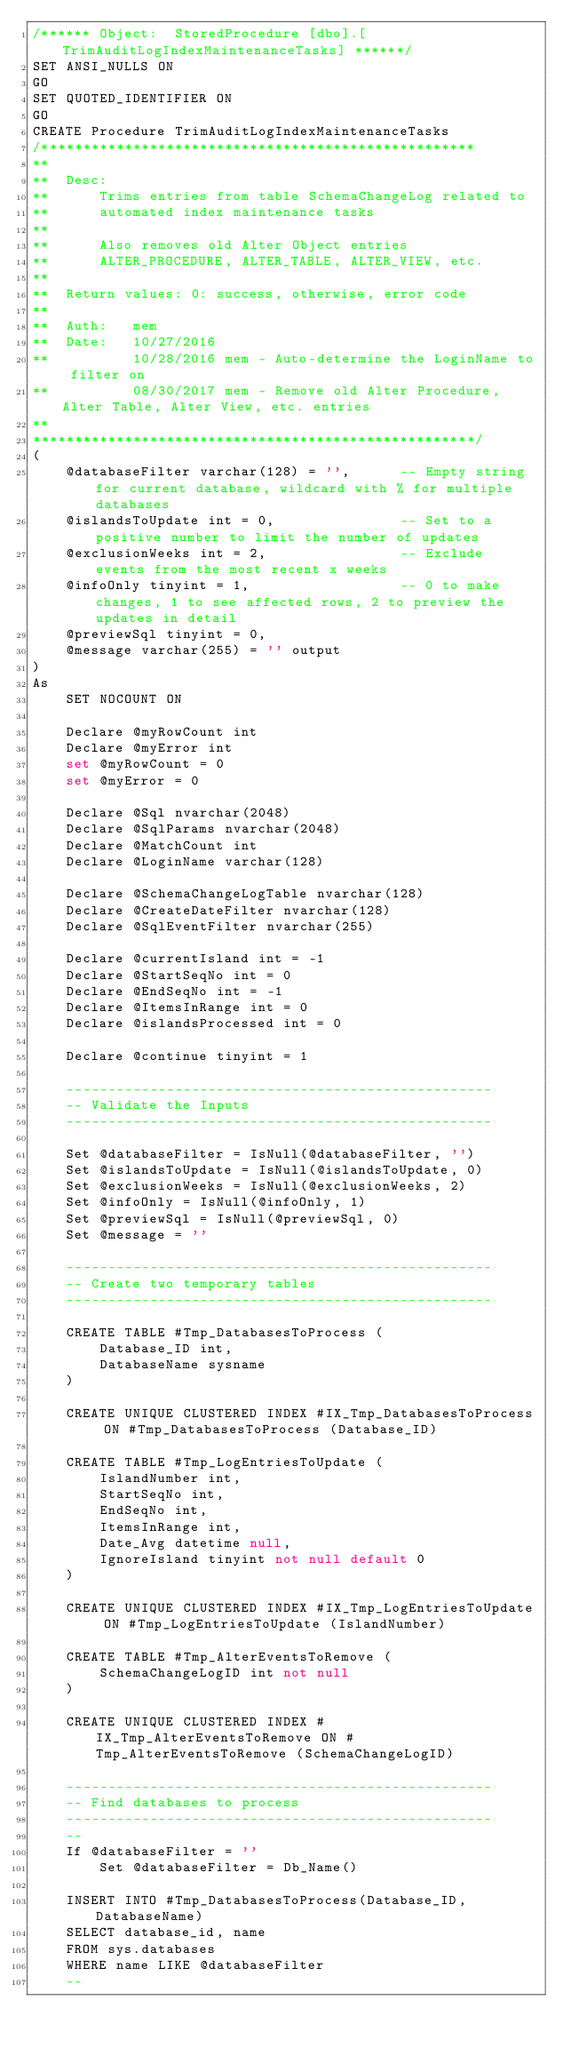<code> <loc_0><loc_0><loc_500><loc_500><_SQL_>/****** Object:  StoredProcedure [dbo].[TrimAuditLogIndexMaintenanceTasks] ******/
SET ANSI_NULLS ON
GO
SET QUOTED_IDENTIFIER ON
GO
CREATE Procedure TrimAuditLogIndexMaintenanceTasks
/****************************************************
**
**	Desc: 
**		Trims entries from table SchemaChangeLog related to
**		automated index maintenance tasks
**
**		Also removes old Alter Object entries
**		ALTER_PROCEDURE, ALTER_TABLE, ALTER_VIEW, etc.
**
**	Return values: 0: success, otherwise, error code
**
**	Auth:	mem
**	Date:	10/27/2016
**			10/28/2016 mem - Auto-determine the LoginName to filter on
**			08/30/2017 mem - Remove old Alter Procedure, Alter Table, Alter View, etc. entries
**    
*****************************************************/
(
	@databaseFilter varchar(128) = '',		-- Empty string for current database, wildcard with % for multiple databases
	@islandsToUpdate int = 0,				-- Set to a positive number to limit the number of updates
	@exclusionWeeks int = 2,				-- Exclude events from the most recent x weeks
	@infoOnly tinyint = 1,					-- 0 to make changes, 1 to see affected rows, 2 to preview the updates in detail
	@previewSql tinyint = 0,
	@message varchar(255) = '' output
)
As
	SET NOCOUNT ON
	
	Declare @myRowCount int
	Declare @myError int
	set @myRowCount = 0
	set @myError = 0

	Declare @Sql nvarchar(2048)
	Declare @SqlParams nvarchar(2048)
	Declare @MatchCount int
	Declare @LoginName varchar(128)
	
	Declare @SchemaChangeLogTable nvarchar(128)
	Declare @CreateDateFilter nvarchar(128)
	Declare @SqlEventFilter nvarchar(255)
	
	Declare @currentIsland int = -1
	Declare @StartSeqNo int = 0
	Declare @EndSeqNo int = -1
	Declare @ItemsInRange int = 0
	Declare @islandsProcessed int = 0
	
	Declare @continue tinyint = 1
	
	---------------------------------------------------
	-- Validate the Inputs
	---------------------------------------------------
	
	Set @databaseFilter = IsNull(@databaseFilter, '')
	Set @islandsToUpdate = IsNull(@islandsToUpdate, 0)
	Set @exclusionWeeks = IsNull(@exclusionWeeks, 2)
	Set @infoOnly = IsNull(@infoOnly, 1)
	Set @previewSql = IsNull(@previewSql, 0)
	Set @message = ''

	---------------------------------------------------
	-- Create two temporary tables
	---------------------------------------------------

	CREATE TABLE #Tmp_DatabasesToProcess (
		Database_ID int,
		DatabaseName sysname
	)
	
	CREATE UNIQUE CLUSTERED INDEX #IX_Tmp_DatabasesToProcess ON #Tmp_DatabasesToProcess (Database_ID)
	
	CREATE TABLE #Tmp_LogEntriesToUpdate (
		IslandNumber int,
		StartSeqNo int,
		EndSeqNo int,
		ItemsInRange int,
		Date_Avg datetime null,
		IgnoreIsland tinyint not null default 0
	)

	CREATE UNIQUE CLUSTERED INDEX #IX_Tmp_LogEntriesToUpdate ON #Tmp_LogEntriesToUpdate (IslandNumber)
	
	CREATE TABLE #Tmp_AlterEventsToRemove (
		SchemaChangeLogID int not null
	)	
	
	CREATE UNIQUE CLUSTERED INDEX #IX_Tmp_AlterEventsToRemove ON #Tmp_AlterEventsToRemove (SchemaChangeLogID)	
	
	---------------------------------------------------
	-- Find databases to process
	---------------------------------------------------
	--
	If @databaseFilter = ''
		Set @databaseFilter = Db_Name()
		
	INSERT INTO #Tmp_DatabasesToProcess(Database_ID, DatabaseName)
	SELECT database_id, name
	FROM sys.databases
	WHERE name LIKE @databaseFilter
	--</code> 